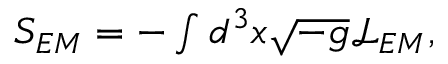Convert formula to latex. <formula><loc_0><loc_0><loc_500><loc_500>\begin{array} { r } { S _ { E M } = - \int d ^ { 3 } x \sqrt { - g } \mathcal { L } _ { E M } , } \end{array}</formula> 